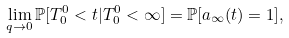<formula> <loc_0><loc_0><loc_500><loc_500>\lim _ { q \rightarrow 0 } { \mathbb { P } } [ T ^ { 0 } _ { 0 } < t | T ^ { 0 } _ { 0 } < \infty ] = { \mathbb { P } } [ a _ { \infty } ( t ) = 1 ] ,</formula> 